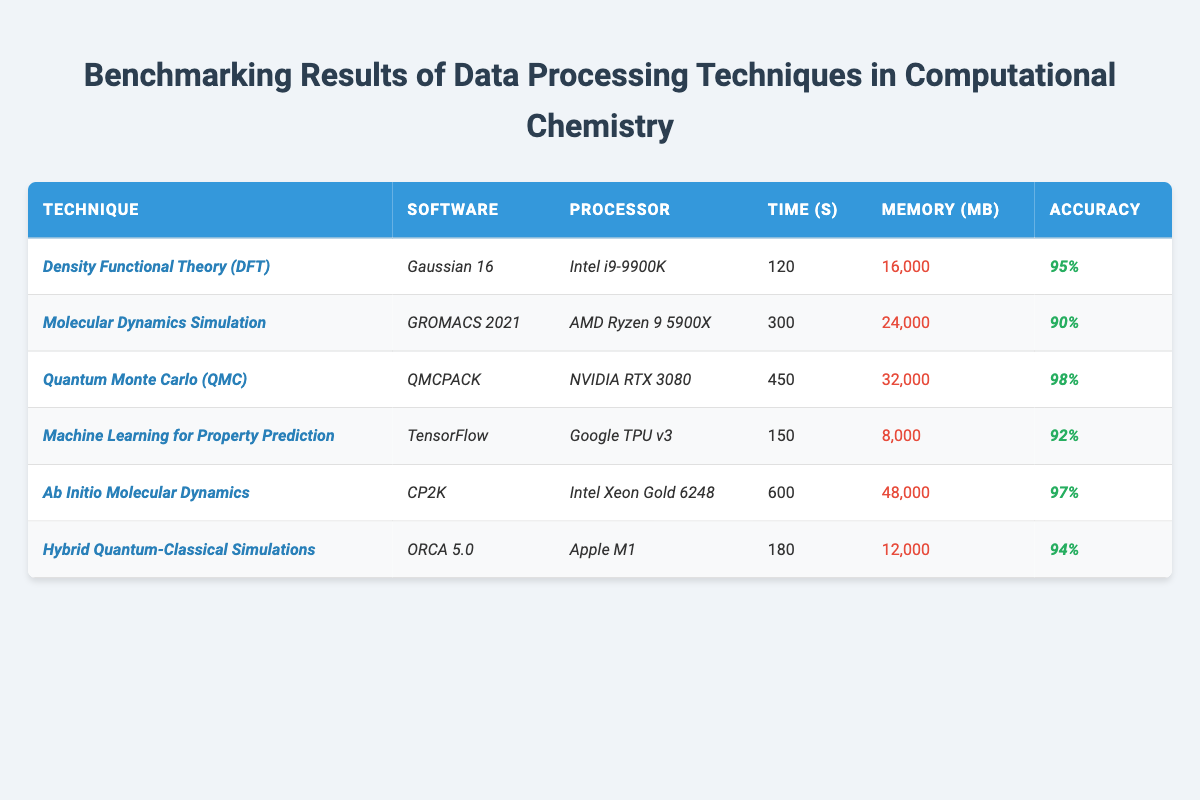What is the time taken by the *Quantum Monte Carlo (QMC)* technique? Looking at the table, under the time column for the technique *Quantum Monte Carlo (QMC)*, the value is 450 seconds.
Answer: 450 seconds Which technique has the highest accuracy? By examining the accuracy column, *Quantum Monte Carlo (QMC)* has the highest accuracy value of 98%.
Answer: *Quantum Monte Carlo (QMC)* What is the processor used for the *Machine Learning for Property Prediction* technique? Referring to the table, the processor listed for the technique *Machine Learning for Property Prediction* is *Google TPU v3*.
Answer: *Google TPU v3* What is the total memory usage for the two techniques with the highest accuracy? The techniques with the highest accuracy are *Quantum Monte Carlo (QMC)* (32,000 MB) and *Ab Initio Molecular Dynamics* (48,000 MB). Adding these together: 32,000 + 48,000 = 80,000 MB.
Answer: 80,000 MB Which technique requires more memory: *Density Functional Theory (DFT)* or *Hybrid Quantum-Classical Simulations*? From the table, *Density Functional Theory (DFT)* requires 16,000 MB, while *Hybrid Quantum-Classical Simulations* requires 12,000 MB. Therefore, *Density Functional Theory (DFT)* requires more memory.
Answer: *Density Functional Theory (DFT)* What is the average time taken by the techniques? The time taken by each technique is: 120, 300, 450, 150, 600, 180 seconds. Adding these up gives 1800 seconds, and dividing by 6 (the number of techniques), the average is 300 seconds.
Answer: 300 seconds Is the memory usage of *Ab Initio Molecular Dynamics* greater than 30,000 MB? According to the table, *Ab Initio Molecular Dynamics* uses 48,000 MB of memory, which is indeed greater than 30,000 MB.
Answer: Yes Which software is used with the technique that takes the least time? Checking the time taken for each technique, *Machine Learning for Property Prediction* has the lowest time at 150 seconds, and it uses *TensorFlow*.
Answer: *TensorFlow* 